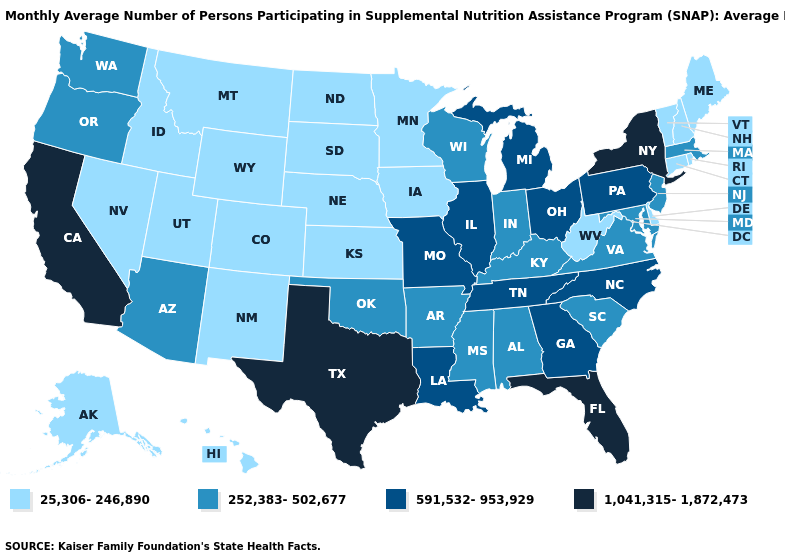What is the value of New York?
Concise answer only. 1,041,315-1,872,473. What is the highest value in states that border North Dakota?
Short answer required. 25,306-246,890. Is the legend a continuous bar?
Quick response, please. No. Does Kentucky have the highest value in the USA?
Short answer required. No. What is the value of Virginia?
Give a very brief answer. 252,383-502,677. Does the first symbol in the legend represent the smallest category?
Give a very brief answer. Yes. What is the value of Kansas?
Keep it brief. 25,306-246,890. What is the highest value in the USA?
Write a very short answer. 1,041,315-1,872,473. Name the states that have a value in the range 252,383-502,677?
Keep it brief. Alabama, Arizona, Arkansas, Indiana, Kentucky, Maryland, Massachusetts, Mississippi, New Jersey, Oklahoma, Oregon, South Carolina, Virginia, Washington, Wisconsin. What is the value of Alaska?
Answer briefly. 25,306-246,890. Which states have the highest value in the USA?
Keep it brief. California, Florida, New York, Texas. Does New Jersey have the lowest value in the Northeast?
Give a very brief answer. No. Name the states that have a value in the range 25,306-246,890?
Quick response, please. Alaska, Colorado, Connecticut, Delaware, Hawaii, Idaho, Iowa, Kansas, Maine, Minnesota, Montana, Nebraska, Nevada, New Hampshire, New Mexico, North Dakota, Rhode Island, South Dakota, Utah, Vermont, West Virginia, Wyoming. Name the states that have a value in the range 252,383-502,677?
Quick response, please. Alabama, Arizona, Arkansas, Indiana, Kentucky, Maryland, Massachusetts, Mississippi, New Jersey, Oklahoma, Oregon, South Carolina, Virginia, Washington, Wisconsin. 